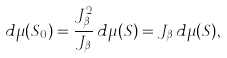Convert formula to latex. <formula><loc_0><loc_0><loc_500><loc_500>d \mu ( S _ { 0 } ) = \frac { J _ { \beta } ^ { 2 } } { J _ { \beta } } \, d \mu ( S ) = J _ { \beta } \, d \mu ( S ) ,</formula> 